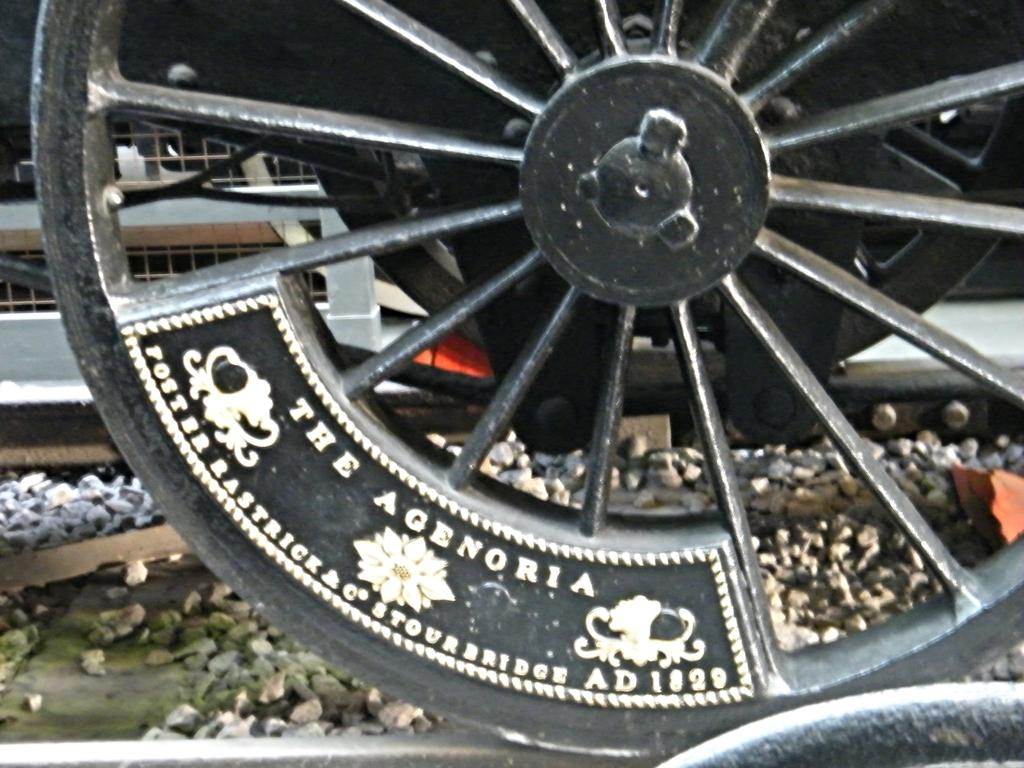<image>
Present a compact description of the photo's key features. A wheel that says the Agenoria on it on a track. 